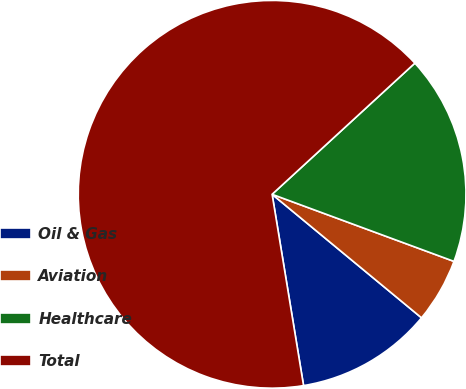Convert chart. <chart><loc_0><loc_0><loc_500><loc_500><pie_chart><fcel>Oil & Gas<fcel>Aviation<fcel>Healthcare<fcel>Total<nl><fcel>11.41%<fcel>5.37%<fcel>17.45%<fcel>65.76%<nl></chart> 